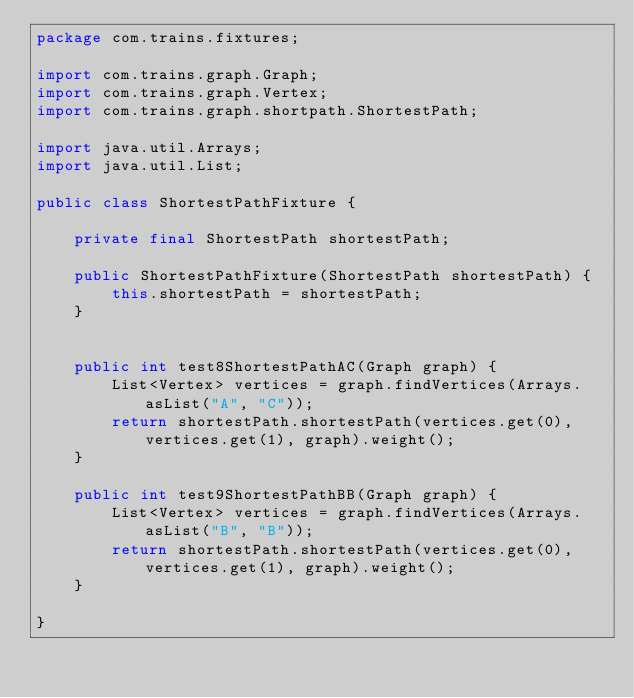Convert code to text. <code><loc_0><loc_0><loc_500><loc_500><_Java_>package com.trains.fixtures;

import com.trains.graph.Graph;
import com.trains.graph.Vertex;
import com.trains.graph.shortpath.ShortestPath;

import java.util.Arrays;
import java.util.List;

public class ShortestPathFixture {

    private final ShortestPath shortestPath;

    public ShortestPathFixture(ShortestPath shortestPath) {
        this.shortestPath = shortestPath;
    }


    public int test8ShortestPathAC(Graph graph) {
        List<Vertex> vertices = graph.findVertices(Arrays.asList("A", "C"));
        return shortestPath.shortestPath(vertices.get(0), vertices.get(1), graph).weight();
    }

    public int test9ShortestPathBB(Graph graph) {
        List<Vertex> vertices = graph.findVertices(Arrays.asList("B", "B"));
        return shortestPath.shortestPath(vertices.get(0), vertices.get(1), graph).weight();
    }

}
</code> 